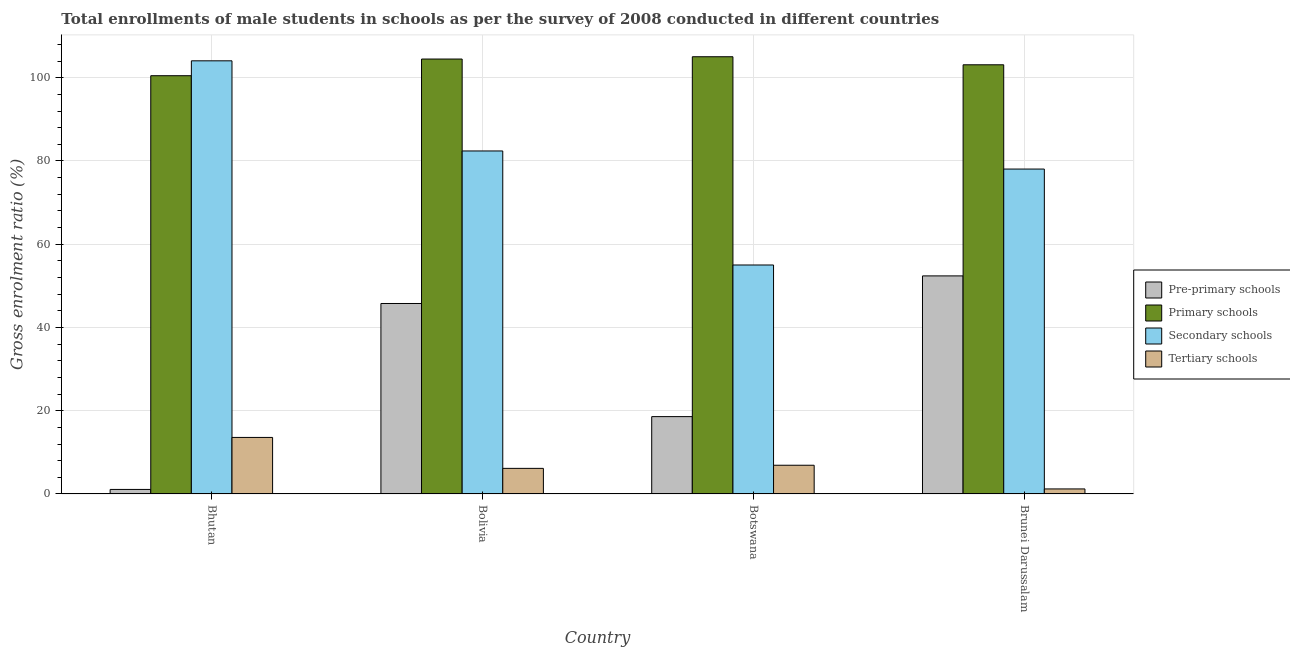How many bars are there on the 3rd tick from the left?
Keep it short and to the point. 4. What is the label of the 2nd group of bars from the left?
Ensure brevity in your answer.  Bolivia. What is the gross enrolment ratio(male) in primary schools in Botswana?
Keep it short and to the point. 105.04. Across all countries, what is the maximum gross enrolment ratio(male) in primary schools?
Your answer should be very brief. 105.04. Across all countries, what is the minimum gross enrolment ratio(male) in tertiary schools?
Provide a succinct answer. 1.21. In which country was the gross enrolment ratio(male) in primary schools maximum?
Your answer should be compact. Botswana. In which country was the gross enrolment ratio(male) in primary schools minimum?
Keep it short and to the point. Bhutan. What is the total gross enrolment ratio(male) in primary schools in the graph?
Give a very brief answer. 413.13. What is the difference between the gross enrolment ratio(male) in secondary schools in Bolivia and that in Brunei Darussalam?
Give a very brief answer. 4.35. What is the difference between the gross enrolment ratio(male) in pre-primary schools in Brunei Darussalam and the gross enrolment ratio(male) in tertiary schools in Botswana?
Give a very brief answer. 45.49. What is the average gross enrolment ratio(male) in pre-primary schools per country?
Your response must be concise. 29.46. What is the difference between the gross enrolment ratio(male) in pre-primary schools and gross enrolment ratio(male) in tertiary schools in Bhutan?
Provide a short and direct response. -12.49. In how many countries, is the gross enrolment ratio(male) in primary schools greater than 84 %?
Your response must be concise. 4. What is the ratio of the gross enrolment ratio(male) in secondary schools in Bolivia to that in Botswana?
Keep it short and to the point. 1.5. Is the gross enrolment ratio(male) in primary schools in Bhutan less than that in Brunei Darussalam?
Offer a terse response. Yes. What is the difference between the highest and the second highest gross enrolment ratio(male) in primary schools?
Provide a short and direct response. 0.55. What is the difference between the highest and the lowest gross enrolment ratio(male) in pre-primary schools?
Offer a very short reply. 51.3. In how many countries, is the gross enrolment ratio(male) in tertiary schools greater than the average gross enrolment ratio(male) in tertiary schools taken over all countries?
Offer a terse response. 1. What does the 3rd bar from the left in Bolivia represents?
Your answer should be very brief. Secondary schools. What does the 4th bar from the right in Bhutan represents?
Keep it short and to the point. Pre-primary schools. Is it the case that in every country, the sum of the gross enrolment ratio(male) in pre-primary schools and gross enrolment ratio(male) in primary schools is greater than the gross enrolment ratio(male) in secondary schools?
Provide a succinct answer. No. What is the difference between two consecutive major ticks on the Y-axis?
Your answer should be compact. 20. Does the graph contain grids?
Provide a succinct answer. Yes. Where does the legend appear in the graph?
Your answer should be very brief. Center right. How many legend labels are there?
Give a very brief answer. 4. How are the legend labels stacked?
Give a very brief answer. Vertical. What is the title of the graph?
Offer a terse response. Total enrollments of male students in schools as per the survey of 2008 conducted in different countries. Does "Third 20% of population" appear as one of the legend labels in the graph?
Your answer should be very brief. No. What is the label or title of the X-axis?
Provide a short and direct response. Country. What is the label or title of the Y-axis?
Offer a very short reply. Gross enrolment ratio (%). What is the Gross enrolment ratio (%) in Pre-primary schools in Bhutan?
Ensure brevity in your answer.  1.09. What is the Gross enrolment ratio (%) of Primary schools in Bhutan?
Your response must be concise. 100.48. What is the Gross enrolment ratio (%) in Secondary schools in Bhutan?
Provide a succinct answer. 104.06. What is the Gross enrolment ratio (%) in Tertiary schools in Bhutan?
Offer a very short reply. 13.58. What is the Gross enrolment ratio (%) of Pre-primary schools in Bolivia?
Keep it short and to the point. 45.76. What is the Gross enrolment ratio (%) of Primary schools in Bolivia?
Ensure brevity in your answer.  104.49. What is the Gross enrolment ratio (%) of Secondary schools in Bolivia?
Make the answer very short. 82.41. What is the Gross enrolment ratio (%) of Tertiary schools in Bolivia?
Give a very brief answer. 6.15. What is the Gross enrolment ratio (%) in Pre-primary schools in Botswana?
Make the answer very short. 18.58. What is the Gross enrolment ratio (%) of Primary schools in Botswana?
Give a very brief answer. 105.04. What is the Gross enrolment ratio (%) in Secondary schools in Botswana?
Offer a terse response. 55.01. What is the Gross enrolment ratio (%) of Tertiary schools in Botswana?
Keep it short and to the point. 6.9. What is the Gross enrolment ratio (%) in Pre-primary schools in Brunei Darussalam?
Your answer should be compact. 52.39. What is the Gross enrolment ratio (%) in Primary schools in Brunei Darussalam?
Make the answer very short. 103.11. What is the Gross enrolment ratio (%) of Secondary schools in Brunei Darussalam?
Your response must be concise. 78.06. What is the Gross enrolment ratio (%) of Tertiary schools in Brunei Darussalam?
Provide a succinct answer. 1.21. Across all countries, what is the maximum Gross enrolment ratio (%) in Pre-primary schools?
Keep it short and to the point. 52.39. Across all countries, what is the maximum Gross enrolment ratio (%) of Primary schools?
Offer a very short reply. 105.04. Across all countries, what is the maximum Gross enrolment ratio (%) in Secondary schools?
Make the answer very short. 104.06. Across all countries, what is the maximum Gross enrolment ratio (%) of Tertiary schools?
Provide a short and direct response. 13.58. Across all countries, what is the minimum Gross enrolment ratio (%) of Pre-primary schools?
Ensure brevity in your answer.  1.09. Across all countries, what is the minimum Gross enrolment ratio (%) in Primary schools?
Offer a terse response. 100.48. Across all countries, what is the minimum Gross enrolment ratio (%) of Secondary schools?
Your response must be concise. 55.01. Across all countries, what is the minimum Gross enrolment ratio (%) of Tertiary schools?
Make the answer very short. 1.21. What is the total Gross enrolment ratio (%) of Pre-primary schools in the graph?
Keep it short and to the point. 117.83. What is the total Gross enrolment ratio (%) of Primary schools in the graph?
Offer a terse response. 413.13. What is the total Gross enrolment ratio (%) in Secondary schools in the graph?
Keep it short and to the point. 319.54. What is the total Gross enrolment ratio (%) in Tertiary schools in the graph?
Ensure brevity in your answer.  27.85. What is the difference between the Gross enrolment ratio (%) in Pre-primary schools in Bhutan and that in Bolivia?
Keep it short and to the point. -44.67. What is the difference between the Gross enrolment ratio (%) in Primary schools in Bhutan and that in Bolivia?
Your answer should be compact. -4.01. What is the difference between the Gross enrolment ratio (%) in Secondary schools in Bhutan and that in Bolivia?
Your answer should be compact. 21.65. What is the difference between the Gross enrolment ratio (%) in Tertiary schools in Bhutan and that in Bolivia?
Your answer should be very brief. 7.43. What is the difference between the Gross enrolment ratio (%) of Pre-primary schools in Bhutan and that in Botswana?
Provide a short and direct response. -17.49. What is the difference between the Gross enrolment ratio (%) of Primary schools in Bhutan and that in Botswana?
Offer a very short reply. -4.56. What is the difference between the Gross enrolment ratio (%) of Secondary schools in Bhutan and that in Botswana?
Make the answer very short. 49.05. What is the difference between the Gross enrolment ratio (%) in Tertiary schools in Bhutan and that in Botswana?
Provide a succinct answer. 6.68. What is the difference between the Gross enrolment ratio (%) in Pre-primary schools in Bhutan and that in Brunei Darussalam?
Your answer should be compact. -51.3. What is the difference between the Gross enrolment ratio (%) in Primary schools in Bhutan and that in Brunei Darussalam?
Keep it short and to the point. -2.63. What is the difference between the Gross enrolment ratio (%) of Secondary schools in Bhutan and that in Brunei Darussalam?
Offer a terse response. 26. What is the difference between the Gross enrolment ratio (%) of Tertiary schools in Bhutan and that in Brunei Darussalam?
Make the answer very short. 12.37. What is the difference between the Gross enrolment ratio (%) in Pre-primary schools in Bolivia and that in Botswana?
Offer a very short reply. 27.18. What is the difference between the Gross enrolment ratio (%) in Primary schools in Bolivia and that in Botswana?
Keep it short and to the point. -0.55. What is the difference between the Gross enrolment ratio (%) of Secondary schools in Bolivia and that in Botswana?
Offer a terse response. 27.4. What is the difference between the Gross enrolment ratio (%) of Tertiary schools in Bolivia and that in Botswana?
Your response must be concise. -0.75. What is the difference between the Gross enrolment ratio (%) of Pre-primary schools in Bolivia and that in Brunei Darussalam?
Provide a short and direct response. -6.63. What is the difference between the Gross enrolment ratio (%) in Primary schools in Bolivia and that in Brunei Darussalam?
Offer a very short reply. 1.38. What is the difference between the Gross enrolment ratio (%) of Secondary schools in Bolivia and that in Brunei Darussalam?
Offer a terse response. 4.35. What is the difference between the Gross enrolment ratio (%) in Tertiary schools in Bolivia and that in Brunei Darussalam?
Offer a very short reply. 4.94. What is the difference between the Gross enrolment ratio (%) in Pre-primary schools in Botswana and that in Brunei Darussalam?
Your response must be concise. -33.81. What is the difference between the Gross enrolment ratio (%) in Primary schools in Botswana and that in Brunei Darussalam?
Your answer should be very brief. 1.93. What is the difference between the Gross enrolment ratio (%) in Secondary schools in Botswana and that in Brunei Darussalam?
Make the answer very short. -23.05. What is the difference between the Gross enrolment ratio (%) in Tertiary schools in Botswana and that in Brunei Darussalam?
Your answer should be very brief. 5.69. What is the difference between the Gross enrolment ratio (%) of Pre-primary schools in Bhutan and the Gross enrolment ratio (%) of Primary schools in Bolivia?
Provide a succinct answer. -103.4. What is the difference between the Gross enrolment ratio (%) in Pre-primary schools in Bhutan and the Gross enrolment ratio (%) in Secondary schools in Bolivia?
Offer a very short reply. -81.32. What is the difference between the Gross enrolment ratio (%) of Pre-primary schools in Bhutan and the Gross enrolment ratio (%) of Tertiary schools in Bolivia?
Provide a short and direct response. -5.06. What is the difference between the Gross enrolment ratio (%) in Primary schools in Bhutan and the Gross enrolment ratio (%) in Secondary schools in Bolivia?
Your answer should be compact. 18.08. What is the difference between the Gross enrolment ratio (%) in Primary schools in Bhutan and the Gross enrolment ratio (%) in Tertiary schools in Bolivia?
Keep it short and to the point. 94.33. What is the difference between the Gross enrolment ratio (%) of Secondary schools in Bhutan and the Gross enrolment ratio (%) of Tertiary schools in Bolivia?
Offer a very short reply. 97.91. What is the difference between the Gross enrolment ratio (%) in Pre-primary schools in Bhutan and the Gross enrolment ratio (%) in Primary schools in Botswana?
Keep it short and to the point. -103.95. What is the difference between the Gross enrolment ratio (%) of Pre-primary schools in Bhutan and the Gross enrolment ratio (%) of Secondary schools in Botswana?
Give a very brief answer. -53.92. What is the difference between the Gross enrolment ratio (%) in Pre-primary schools in Bhutan and the Gross enrolment ratio (%) in Tertiary schools in Botswana?
Offer a terse response. -5.81. What is the difference between the Gross enrolment ratio (%) of Primary schools in Bhutan and the Gross enrolment ratio (%) of Secondary schools in Botswana?
Your response must be concise. 45.47. What is the difference between the Gross enrolment ratio (%) in Primary schools in Bhutan and the Gross enrolment ratio (%) in Tertiary schools in Botswana?
Your answer should be compact. 93.58. What is the difference between the Gross enrolment ratio (%) in Secondary schools in Bhutan and the Gross enrolment ratio (%) in Tertiary schools in Botswana?
Your answer should be compact. 97.16. What is the difference between the Gross enrolment ratio (%) in Pre-primary schools in Bhutan and the Gross enrolment ratio (%) in Primary schools in Brunei Darussalam?
Your answer should be compact. -102.02. What is the difference between the Gross enrolment ratio (%) of Pre-primary schools in Bhutan and the Gross enrolment ratio (%) of Secondary schools in Brunei Darussalam?
Keep it short and to the point. -76.97. What is the difference between the Gross enrolment ratio (%) in Pre-primary schools in Bhutan and the Gross enrolment ratio (%) in Tertiary schools in Brunei Darussalam?
Give a very brief answer. -0.12. What is the difference between the Gross enrolment ratio (%) of Primary schools in Bhutan and the Gross enrolment ratio (%) of Secondary schools in Brunei Darussalam?
Offer a terse response. 22.43. What is the difference between the Gross enrolment ratio (%) of Primary schools in Bhutan and the Gross enrolment ratio (%) of Tertiary schools in Brunei Darussalam?
Provide a succinct answer. 99.27. What is the difference between the Gross enrolment ratio (%) in Secondary schools in Bhutan and the Gross enrolment ratio (%) in Tertiary schools in Brunei Darussalam?
Offer a very short reply. 102.85. What is the difference between the Gross enrolment ratio (%) in Pre-primary schools in Bolivia and the Gross enrolment ratio (%) in Primary schools in Botswana?
Your response must be concise. -59.28. What is the difference between the Gross enrolment ratio (%) of Pre-primary schools in Bolivia and the Gross enrolment ratio (%) of Secondary schools in Botswana?
Offer a very short reply. -9.25. What is the difference between the Gross enrolment ratio (%) of Pre-primary schools in Bolivia and the Gross enrolment ratio (%) of Tertiary schools in Botswana?
Ensure brevity in your answer.  38.86. What is the difference between the Gross enrolment ratio (%) of Primary schools in Bolivia and the Gross enrolment ratio (%) of Secondary schools in Botswana?
Offer a very short reply. 49.48. What is the difference between the Gross enrolment ratio (%) in Primary schools in Bolivia and the Gross enrolment ratio (%) in Tertiary schools in Botswana?
Provide a short and direct response. 97.59. What is the difference between the Gross enrolment ratio (%) of Secondary schools in Bolivia and the Gross enrolment ratio (%) of Tertiary schools in Botswana?
Provide a succinct answer. 75.51. What is the difference between the Gross enrolment ratio (%) of Pre-primary schools in Bolivia and the Gross enrolment ratio (%) of Primary schools in Brunei Darussalam?
Provide a short and direct response. -57.35. What is the difference between the Gross enrolment ratio (%) of Pre-primary schools in Bolivia and the Gross enrolment ratio (%) of Secondary schools in Brunei Darussalam?
Offer a terse response. -32.3. What is the difference between the Gross enrolment ratio (%) in Pre-primary schools in Bolivia and the Gross enrolment ratio (%) in Tertiary schools in Brunei Darussalam?
Your answer should be very brief. 44.55. What is the difference between the Gross enrolment ratio (%) of Primary schools in Bolivia and the Gross enrolment ratio (%) of Secondary schools in Brunei Darussalam?
Your answer should be compact. 26.43. What is the difference between the Gross enrolment ratio (%) in Primary schools in Bolivia and the Gross enrolment ratio (%) in Tertiary schools in Brunei Darussalam?
Your answer should be very brief. 103.28. What is the difference between the Gross enrolment ratio (%) of Secondary schools in Bolivia and the Gross enrolment ratio (%) of Tertiary schools in Brunei Darussalam?
Provide a succinct answer. 81.2. What is the difference between the Gross enrolment ratio (%) in Pre-primary schools in Botswana and the Gross enrolment ratio (%) in Primary schools in Brunei Darussalam?
Your answer should be very brief. -84.53. What is the difference between the Gross enrolment ratio (%) of Pre-primary schools in Botswana and the Gross enrolment ratio (%) of Secondary schools in Brunei Darussalam?
Your answer should be compact. -59.48. What is the difference between the Gross enrolment ratio (%) of Pre-primary schools in Botswana and the Gross enrolment ratio (%) of Tertiary schools in Brunei Darussalam?
Your response must be concise. 17.37. What is the difference between the Gross enrolment ratio (%) in Primary schools in Botswana and the Gross enrolment ratio (%) in Secondary schools in Brunei Darussalam?
Offer a very short reply. 26.98. What is the difference between the Gross enrolment ratio (%) in Primary schools in Botswana and the Gross enrolment ratio (%) in Tertiary schools in Brunei Darussalam?
Your response must be concise. 103.83. What is the difference between the Gross enrolment ratio (%) in Secondary schools in Botswana and the Gross enrolment ratio (%) in Tertiary schools in Brunei Darussalam?
Keep it short and to the point. 53.8. What is the average Gross enrolment ratio (%) of Pre-primary schools per country?
Ensure brevity in your answer.  29.46. What is the average Gross enrolment ratio (%) in Primary schools per country?
Keep it short and to the point. 103.28. What is the average Gross enrolment ratio (%) of Secondary schools per country?
Provide a succinct answer. 79.88. What is the average Gross enrolment ratio (%) of Tertiary schools per country?
Give a very brief answer. 6.96. What is the difference between the Gross enrolment ratio (%) of Pre-primary schools and Gross enrolment ratio (%) of Primary schools in Bhutan?
Your response must be concise. -99.39. What is the difference between the Gross enrolment ratio (%) in Pre-primary schools and Gross enrolment ratio (%) in Secondary schools in Bhutan?
Your response must be concise. -102.97. What is the difference between the Gross enrolment ratio (%) in Pre-primary schools and Gross enrolment ratio (%) in Tertiary schools in Bhutan?
Keep it short and to the point. -12.49. What is the difference between the Gross enrolment ratio (%) in Primary schools and Gross enrolment ratio (%) in Secondary schools in Bhutan?
Offer a very short reply. -3.58. What is the difference between the Gross enrolment ratio (%) in Primary schools and Gross enrolment ratio (%) in Tertiary schools in Bhutan?
Your answer should be compact. 86.9. What is the difference between the Gross enrolment ratio (%) of Secondary schools and Gross enrolment ratio (%) of Tertiary schools in Bhutan?
Your response must be concise. 90.48. What is the difference between the Gross enrolment ratio (%) of Pre-primary schools and Gross enrolment ratio (%) of Primary schools in Bolivia?
Offer a very short reply. -58.73. What is the difference between the Gross enrolment ratio (%) in Pre-primary schools and Gross enrolment ratio (%) in Secondary schools in Bolivia?
Offer a very short reply. -36.65. What is the difference between the Gross enrolment ratio (%) of Pre-primary schools and Gross enrolment ratio (%) of Tertiary schools in Bolivia?
Provide a short and direct response. 39.61. What is the difference between the Gross enrolment ratio (%) in Primary schools and Gross enrolment ratio (%) in Secondary schools in Bolivia?
Provide a short and direct response. 22.08. What is the difference between the Gross enrolment ratio (%) in Primary schools and Gross enrolment ratio (%) in Tertiary schools in Bolivia?
Provide a short and direct response. 98.34. What is the difference between the Gross enrolment ratio (%) in Secondary schools and Gross enrolment ratio (%) in Tertiary schools in Bolivia?
Your response must be concise. 76.26. What is the difference between the Gross enrolment ratio (%) in Pre-primary schools and Gross enrolment ratio (%) in Primary schools in Botswana?
Provide a short and direct response. -86.46. What is the difference between the Gross enrolment ratio (%) in Pre-primary schools and Gross enrolment ratio (%) in Secondary schools in Botswana?
Offer a terse response. -36.43. What is the difference between the Gross enrolment ratio (%) of Pre-primary schools and Gross enrolment ratio (%) of Tertiary schools in Botswana?
Ensure brevity in your answer.  11.68. What is the difference between the Gross enrolment ratio (%) of Primary schools and Gross enrolment ratio (%) of Secondary schools in Botswana?
Your answer should be compact. 50.03. What is the difference between the Gross enrolment ratio (%) of Primary schools and Gross enrolment ratio (%) of Tertiary schools in Botswana?
Provide a succinct answer. 98.14. What is the difference between the Gross enrolment ratio (%) in Secondary schools and Gross enrolment ratio (%) in Tertiary schools in Botswana?
Your answer should be very brief. 48.11. What is the difference between the Gross enrolment ratio (%) in Pre-primary schools and Gross enrolment ratio (%) in Primary schools in Brunei Darussalam?
Provide a succinct answer. -50.72. What is the difference between the Gross enrolment ratio (%) of Pre-primary schools and Gross enrolment ratio (%) of Secondary schools in Brunei Darussalam?
Keep it short and to the point. -25.67. What is the difference between the Gross enrolment ratio (%) in Pre-primary schools and Gross enrolment ratio (%) in Tertiary schools in Brunei Darussalam?
Keep it short and to the point. 51.18. What is the difference between the Gross enrolment ratio (%) in Primary schools and Gross enrolment ratio (%) in Secondary schools in Brunei Darussalam?
Your answer should be very brief. 25.05. What is the difference between the Gross enrolment ratio (%) in Primary schools and Gross enrolment ratio (%) in Tertiary schools in Brunei Darussalam?
Keep it short and to the point. 101.9. What is the difference between the Gross enrolment ratio (%) of Secondary schools and Gross enrolment ratio (%) of Tertiary schools in Brunei Darussalam?
Your answer should be compact. 76.85. What is the ratio of the Gross enrolment ratio (%) in Pre-primary schools in Bhutan to that in Bolivia?
Ensure brevity in your answer.  0.02. What is the ratio of the Gross enrolment ratio (%) in Primary schools in Bhutan to that in Bolivia?
Your response must be concise. 0.96. What is the ratio of the Gross enrolment ratio (%) of Secondary schools in Bhutan to that in Bolivia?
Offer a terse response. 1.26. What is the ratio of the Gross enrolment ratio (%) in Tertiary schools in Bhutan to that in Bolivia?
Offer a terse response. 2.21. What is the ratio of the Gross enrolment ratio (%) of Pre-primary schools in Bhutan to that in Botswana?
Your response must be concise. 0.06. What is the ratio of the Gross enrolment ratio (%) in Primary schools in Bhutan to that in Botswana?
Your answer should be very brief. 0.96. What is the ratio of the Gross enrolment ratio (%) in Secondary schools in Bhutan to that in Botswana?
Give a very brief answer. 1.89. What is the ratio of the Gross enrolment ratio (%) in Tertiary schools in Bhutan to that in Botswana?
Your answer should be compact. 1.97. What is the ratio of the Gross enrolment ratio (%) in Pre-primary schools in Bhutan to that in Brunei Darussalam?
Make the answer very short. 0.02. What is the ratio of the Gross enrolment ratio (%) of Primary schools in Bhutan to that in Brunei Darussalam?
Offer a very short reply. 0.97. What is the ratio of the Gross enrolment ratio (%) in Secondary schools in Bhutan to that in Brunei Darussalam?
Provide a succinct answer. 1.33. What is the ratio of the Gross enrolment ratio (%) of Tertiary schools in Bhutan to that in Brunei Darussalam?
Ensure brevity in your answer.  11.23. What is the ratio of the Gross enrolment ratio (%) in Pre-primary schools in Bolivia to that in Botswana?
Offer a very short reply. 2.46. What is the ratio of the Gross enrolment ratio (%) of Primary schools in Bolivia to that in Botswana?
Keep it short and to the point. 0.99. What is the ratio of the Gross enrolment ratio (%) of Secondary schools in Bolivia to that in Botswana?
Keep it short and to the point. 1.5. What is the ratio of the Gross enrolment ratio (%) of Tertiary schools in Bolivia to that in Botswana?
Offer a terse response. 0.89. What is the ratio of the Gross enrolment ratio (%) in Pre-primary schools in Bolivia to that in Brunei Darussalam?
Provide a short and direct response. 0.87. What is the ratio of the Gross enrolment ratio (%) in Primary schools in Bolivia to that in Brunei Darussalam?
Keep it short and to the point. 1.01. What is the ratio of the Gross enrolment ratio (%) of Secondary schools in Bolivia to that in Brunei Darussalam?
Make the answer very short. 1.06. What is the ratio of the Gross enrolment ratio (%) in Tertiary schools in Bolivia to that in Brunei Darussalam?
Your response must be concise. 5.08. What is the ratio of the Gross enrolment ratio (%) of Pre-primary schools in Botswana to that in Brunei Darussalam?
Give a very brief answer. 0.35. What is the ratio of the Gross enrolment ratio (%) in Primary schools in Botswana to that in Brunei Darussalam?
Offer a terse response. 1.02. What is the ratio of the Gross enrolment ratio (%) in Secondary schools in Botswana to that in Brunei Darussalam?
Keep it short and to the point. 0.7. What is the ratio of the Gross enrolment ratio (%) in Tertiary schools in Botswana to that in Brunei Darussalam?
Keep it short and to the point. 5.7. What is the difference between the highest and the second highest Gross enrolment ratio (%) of Pre-primary schools?
Provide a succinct answer. 6.63. What is the difference between the highest and the second highest Gross enrolment ratio (%) of Primary schools?
Your answer should be very brief. 0.55. What is the difference between the highest and the second highest Gross enrolment ratio (%) in Secondary schools?
Ensure brevity in your answer.  21.65. What is the difference between the highest and the second highest Gross enrolment ratio (%) of Tertiary schools?
Your response must be concise. 6.68. What is the difference between the highest and the lowest Gross enrolment ratio (%) of Pre-primary schools?
Make the answer very short. 51.3. What is the difference between the highest and the lowest Gross enrolment ratio (%) in Primary schools?
Provide a short and direct response. 4.56. What is the difference between the highest and the lowest Gross enrolment ratio (%) in Secondary schools?
Your answer should be very brief. 49.05. What is the difference between the highest and the lowest Gross enrolment ratio (%) in Tertiary schools?
Your answer should be very brief. 12.37. 